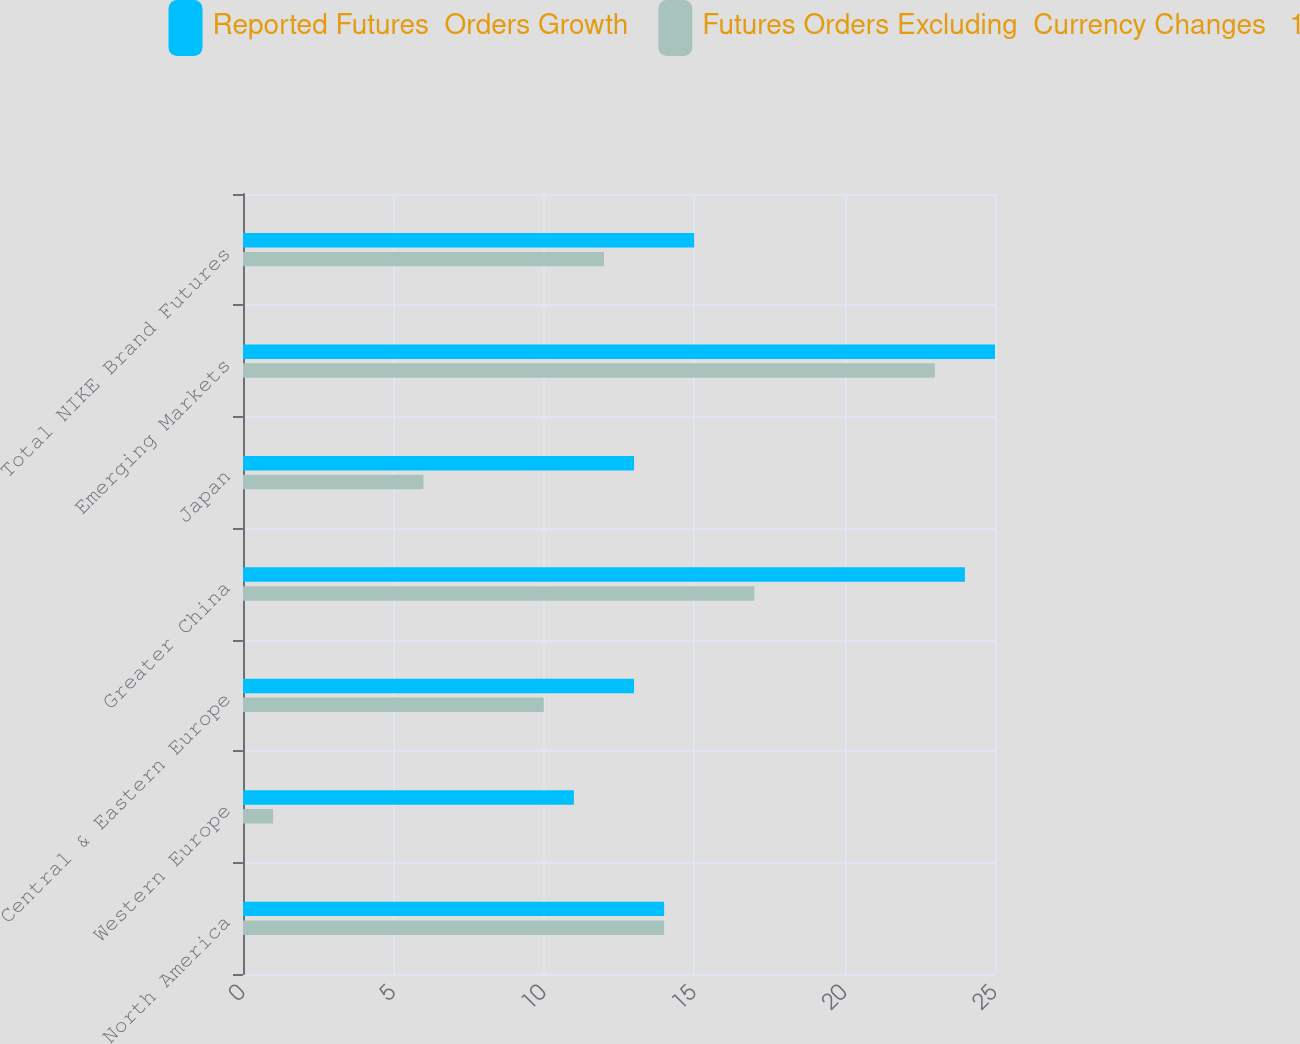Convert chart. <chart><loc_0><loc_0><loc_500><loc_500><stacked_bar_chart><ecel><fcel>North America<fcel>Western Europe<fcel>Central & Eastern Europe<fcel>Greater China<fcel>Japan<fcel>Emerging Markets<fcel>Total NIKE Brand Futures<nl><fcel>Reported Futures  Orders Growth<fcel>14<fcel>11<fcel>13<fcel>24<fcel>13<fcel>25<fcel>15<nl><fcel>Futures Orders Excluding  Currency Changes   1<fcel>14<fcel>1<fcel>10<fcel>17<fcel>6<fcel>23<fcel>12<nl></chart> 